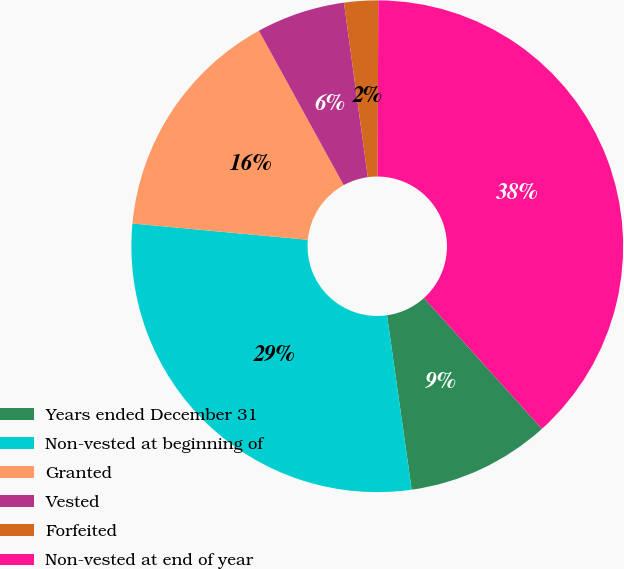Convert chart. <chart><loc_0><loc_0><loc_500><loc_500><pie_chart><fcel>Years ended December 31<fcel>Non-vested at beginning of<fcel>Granted<fcel>Vested<fcel>Forfeited<fcel>Non-vested at end of year<nl><fcel>9.44%<fcel>28.71%<fcel>15.53%<fcel>5.83%<fcel>2.23%<fcel>38.25%<nl></chart> 